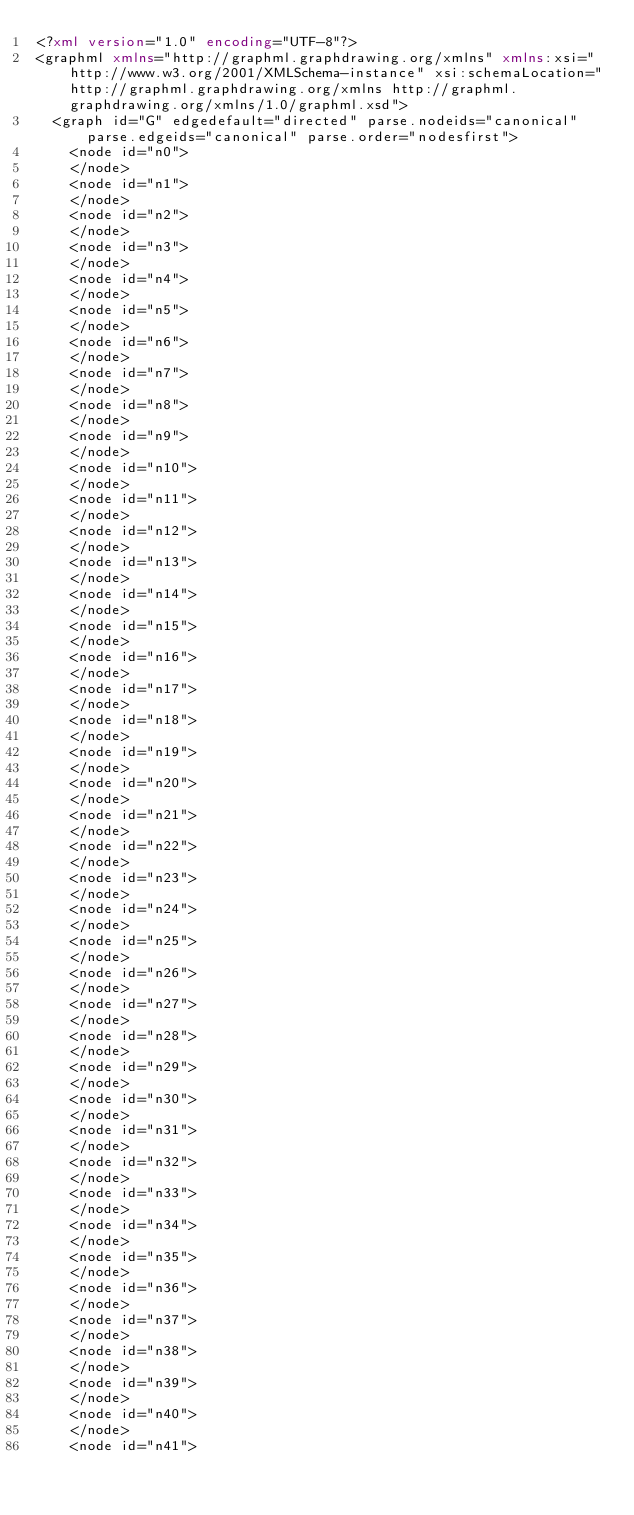<code> <loc_0><loc_0><loc_500><loc_500><_XML_><?xml version="1.0" encoding="UTF-8"?>
<graphml xmlns="http://graphml.graphdrawing.org/xmlns" xmlns:xsi="http://www.w3.org/2001/XMLSchema-instance" xsi:schemaLocation="http://graphml.graphdrawing.org/xmlns http://graphml.graphdrawing.org/xmlns/1.0/graphml.xsd">
  <graph id="G" edgedefault="directed" parse.nodeids="canonical" parse.edgeids="canonical" parse.order="nodesfirst">
    <node id="n0">
    </node>
    <node id="n1">
    </node>
    <node id="n2">
    </node>
    <node id="n3">
    </node>
    <node id="n4">
    </node>
    <node id="n5">
    </node>
    <node id="n6">
    </node>
    <node id="n7">
    </node>
    <node id="n8">
    </node>
    <node id="n9">
    </node>
    <node id="n10">
    </node>
    <node id="n11">
    </node>
    <node id="n12">
    </node>
    <node id="n13">
    </node>
    <node id="n14">
    </node>
    <node id="n15">
    </node>
    <node id="n16">
    </node>
    <node id="n17">
    </node>
    <node id="n18">
    </node>
    <node id="n19">
    </node>
    <node id="n20">
    </node>
    <node id="n21">
    </node>
    <node id="n22">
    </node>
    <node id="n23">
    </node>
    <node id="n24">
    </node>
    <node id="n25">
    </node>
    <node id="n26">
    </node>
    <node id="n27">
    </node>
    <node id="n28">
    </node>
    <node id="n29">
    </node>
    <node id="n30">
    </node>
    <node id="n31">
    </node>
    <node id="n32">
    </node>
    <node id="n33">
    </node>
    <node id="n34">
    </node>
    <node id="n35">
    </node>
    <node id="n36">
    </node>
    <node id="n37">
    </node>
    <node id="n38">
    </node>
    <node id="n39">
    </node>
    <node id="n40">
    </node>
    <node id="n41"></code> 